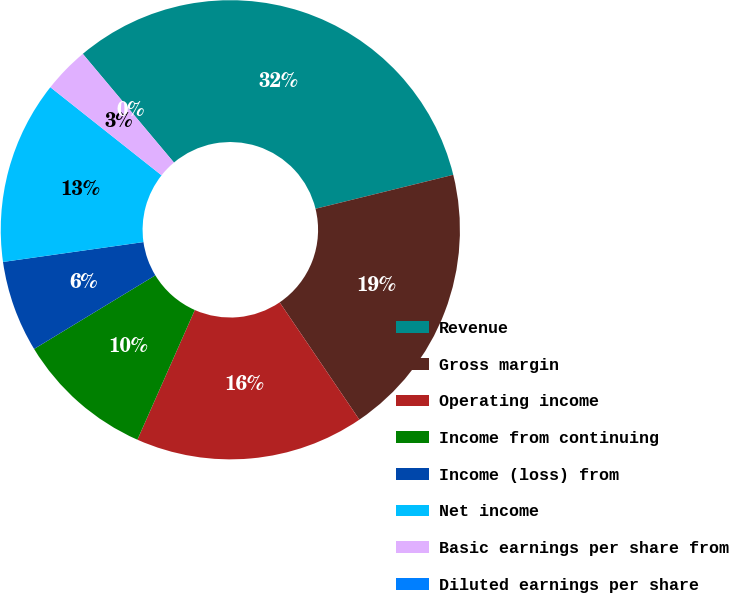<chart> <loc_0><loc_0><loc_500><loc_500><pie_chart><fcel>Revenue<fcel>Gross margin<fcel>Operating income<fcel>Income from continuing<fcel>Income (loss) from<fcel>Net income<fcel>Basic earnings per share from<fcel>Diluted earnings per share<nl><fcel>32.26%<fcel>19.35%<fcel>16.13%<fcel>9.68%<fcel>6.45%<fcel>12.9%<fcel>3.23%<fcel>0.0%<nl></chart> 